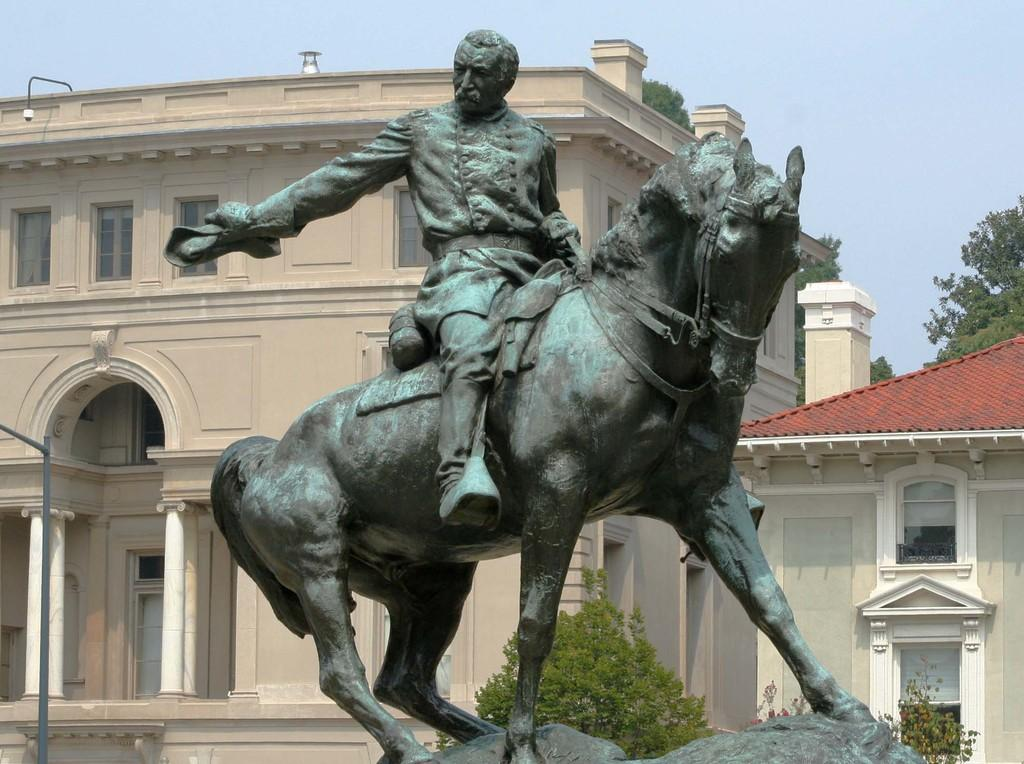What is the main subject of the image? There is a sculpture of a person and a horse in the image. What can be seen in the background of the image? There are buildings with windows and trees in the background of the image. What other object is present in the image? There is a pole in the image. What is the color of the sky in the image? The sky is blue in color. How many pails are hanging from the sculpture in the image? There are no pails present in the image; it features a sculpture of a person and a horse. What type of shade is provided by the sculpture in the image? There is no shade provided by the sculpture in the image; it is a stationary sculpture. 